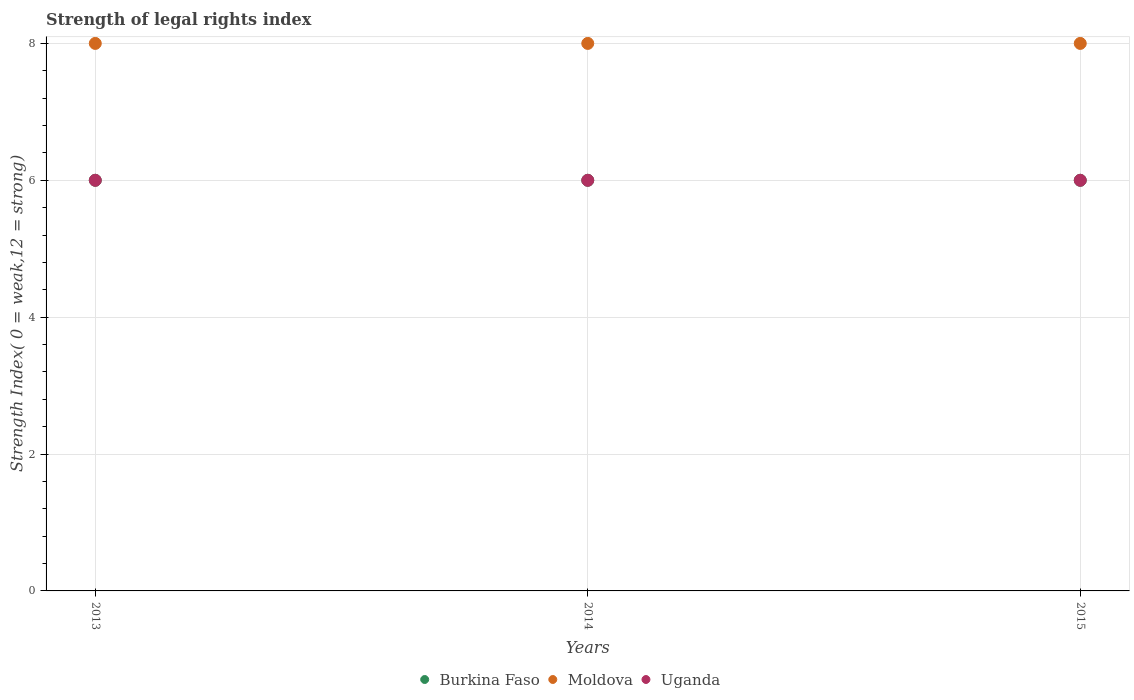What is the strength index in Moldova in 2015?
Offer a very short reply. 8. Across all years, what is the maximum strength index in Moldova?
Give a very brief answer. 8. Across all years, what is the minimum strength index in Moldova?
Make the answer very short. 8. In which year was the strength index in Uganda maximum?
Your response must be concise. 2013. What is the total strength index in Burkina Faso in the graph?
Provide a short and direct response. 18. What is the difference between the strength index in Moldova in 2015 and the strength index in Uganda in 2014?
Ensure brevity in your answer.  2. What is the average strength index in Burkina Faso per year?
Offer a terse response. 6. In the year 2014, what is the difference between the strength index in Moldova and strength index in Burkina Faso?
Ensure brevity in your answer.  2. Is the difference between the strength index in Moldova in 2014 and 2015 greater than the difference between the strength index in Burkina Faso in 2014 and 2015?
Make the answer very short. No. Is it the case that in every year, the sum of the strength index in Uganda and strength index in Moldova  is greater than the strength index in Burkina Faso?
Provide a succinct answer. Yes. Does the strength index in Uganda monotonically increase over the years?
Give a very brief answer. No. Is the strength index in Burkina Faso strictly greater than the strength index in Moldova over the years?
Offer a very short reply. No. What is the difference between two consecutive major ticks on the Y-axis?
Make the answer very short. 2. Are the values on the major ticks of Y-axis written in scientific E-notation?
Your answer should be very brief. No. How are the legend labels stacked?
Offer a terse response. Horizontal. What is the title of the graph?
Your response must be concise. Strength of legal rights index. What is the label or title of the X-axis?
Your answer should be very brief. Years. What is the label or title of the Y-axis?
Your response must be concise. Strength Index( 0 = weak,12 = strong). What is the Strength Index( 0 = weak,12 = strong) in Burkina Faso in 2013?
Your answer should be very brief. 6. What is the Strength Index( 0 = weak,12 = strong) in Uganda in 2013?
Offer a very short reply. 6. What is the Strength Index( 0 = weak,12 = strong) of Burkina Faso in 2014?
Provide a succinct answer. 6. What is the Strength Index( 0 = weak,12 = strong) in Moldova in 2014?
Give a very brief answer. 8. What is the Strength Index( 0 = weak,12 = strong) in Uganda in 2014?
Your answer should be very brief. 6. What is the Strength Index( 0 = weak,12 = strong) of Burkina Faso in 2015?
Offer a terse response. 6. Across all years, what is the maximum Strength Index( 0 = weak,12 = strong) of Burkina Faso?
Your answer should be compact. 6. Across all years, what is the minimum Strength Index( 0 = weak,12 = strong) of Uganda?
Ensure brevity in your answer.  6. What is the total Strength Index( 0 = weak,12 = strong) of Moldova in the graph?
Make the answer very short. 24. What is the difference between the Strength Index( 0 = weak,12 = strong) in Burkina Faso in 2013 and that in 2014?
Make the answer very short. 0. What is the difference between the Strength Index( 0 = weak,12 = strong) in Moldova in 2013 and that in 2014?
Your response must be concise. 0. What is the difference between the Strength Index( 0 = weak,12 = strong) in Uganda in 2013 and that in 2014?
Offer a very short reply. 0. What is the difference between the Strength Index( 0 = weak,12 = strong) in Burkina Faso in 2013 and that in 2015?
Offer a terse response. 0. What is the difference between the Strength Index( 0 = weak,12 = strong) of Moldova in 2013 and that in 2015?
Offer a terse response. 0. What is the difference between the Strength Index( 0 = weak,12 = strong) in Uganda in 2013 and that in 2015?
Offer a very short reply. 0. What is the difference between the Strength Index( 0 = weak,12 = strong) in Burkina Faso in 2013 and the Strength Index( 0 = weak,12 = strong) in Uganda in 2014?
Offer a terse response. 0. What is the difference between the Strength Index( 0 = weak,12 = strong) in Moldova in 2013 and the Strength Index( 0 = weak,12 = strong) in Uganda in 2014?
Offer a very short reply. 2. What is the difference between the Strength Index( 0 = weak,12 = strong) of Burkina Faso in 2013 and the Strength Index( 0 = weak,12 = strong) of Moldova in 2015?
Your response must be concise. -2. What is the difference between the Strength Index( 0 = weak,12 = strong) of Burkina Faso in 2013 and the Strength Index( 0 = weak,12 = strong) of Uganda in 2015?
Ensure brevity in your answer.  0. What is the difference between the Strength Index( 0 = weak,12 = strong) in Burkina Faso in 2014 and the Strength Index( 0 = weak,12 = strong) in Moldova in 2015?
Your answer should be very brief. -2. What is the difference between the Strength Index( 0 = weak,12 = strong) of Moldova in 2014 and the Strength Index( 0 = weak,12 = strong) of Uganda in 2015?
Your answer should be compact. 2. What is the average Strength Index( 0 = weak,12 = strong) in Burkina Faso per year?
Give a very brief answer. 6. What is the average Strength Index( 0 = weak,12 = strong) in Moldova per year?
Offer a very short reply. 8. What is the average Strength Index( 0 = weak,12 = strong) in Uganda per year?
Make the answer very short. 6. In the year 2013, what is the difference between the Strength Index( 0 = weak,12 = strong) in Burkina Faso and Strength Index( 0 = weak,12 = strong) in Moldova?
Provide a succinct answer. -2. In the year 2013, what is the difference between the Strength Index( 0 = weak,12 = strong) of Burkina Faso and Strength Index( 0 = weak,12 = strong) of Uganda?
Ensure brevity in your answer.  0. In the year 2014, what is the difference between the Strength Index( 0 = weak,12 = strong) in Burkina Faso and Strength Index( 0 = weak,12 = strong) in Uganda?
Your answer should be very brief. 0. In the year 2014, what is the difference between the Strength Index( 0 = weak,12 = strong) of Moldova and Strength Index( 0 = weak,12 = strong) of Uganda?
Your answer should be very brief. 2. In the year 2015, what is the difference between the Strength Index( 0 = weak,12 = strong) of Burkina Faso and Strength Index( 0 = weak,12 = strong) of Moldova?
Give a very brief answer. -2. In the year 2015, what is the difference between the Strength Index( 0 = weak,12 = strong) of Burkina Faso and Strength Index( 0 = weak,12 = strong) of Uganda?
Provide a succinct answer. 0. In the year 2015, what is the difference between the Strength Index( 0 = weak,12 = strong) of Moldova and Strength Index( 0 = weak,12 = strong) of Uganda?
Your answer should be very brief. 2. What is the ratio of the Strength Index( 0 = weak,12 = strong) of Burkina Faso in 2013 to that in 2014?
Offer a very short reply. 1. What is the ratio of the Strength Index( 0 = weak,12 = strong) of Moldova in 2013 to that in 2014?
Offer a terse response. 1. What is the ratio of the Strength Index( 0 = weak,12 = strong) in Uganda in 2013 to that in 2014?
Your answer should be compact. 1. What is the ratio of the Strength Index( 0 = weak,12 = strong) in Burkina Faso in 2013 to that in 2015?
Offer a very short reply. 1. What is the ratio of the Strength Index( 0 = weak,12 = strong) of Moldova in 2013 to that in 2015?
Give a very brief answer. 1. What is the ratio of the Strength Index( 0 = weak,12 = strong) of Burkina Faso in 2014 to that in 2015?
Provide a succinct answer. 1. What is the ratio of the Strength Index( 0 = weak,12 = strong) of Uganda in 2014 to that in 2015?
Provide a succinct answer. 1. What is the difference between the highest and the lowest Strength Index( 0 = weak,12 = strong) of Moldova?
Make the answer very short. 0. 